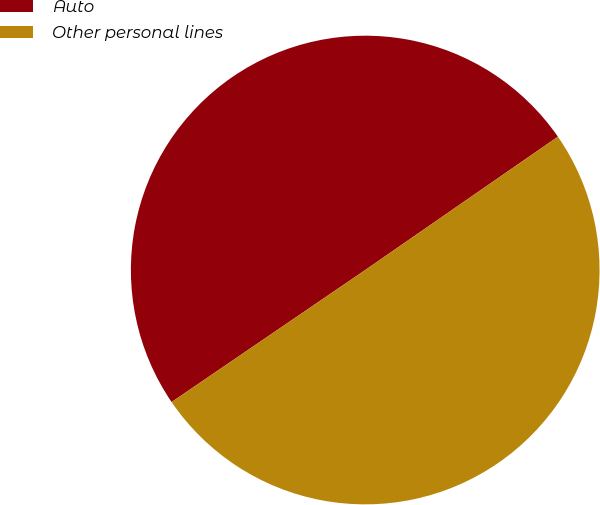Convert chart to OTSL. <chart><loc_0><loc_0><loc_500><loc_500><pie_chart><fcel>Auto<fcel>Other personal lines<nl><fcel>49.89%<fcel>50.11%<nl></chart> 